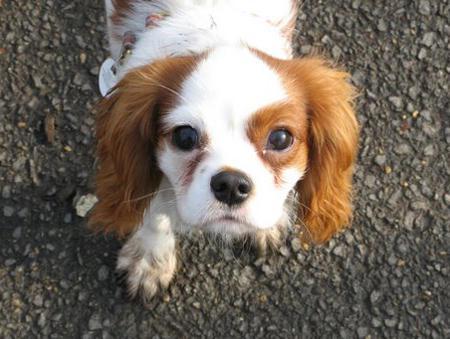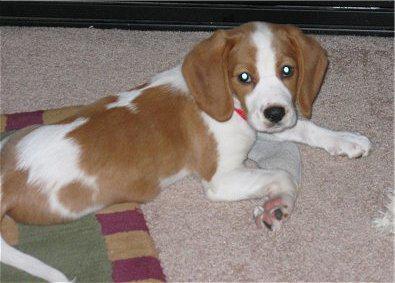The first image is the image on the left, the second image is the image on the right. Assess this claim about the two images: "The dog in the image on the left is outside.". Correct or not? Answer yes or no. Yes. 